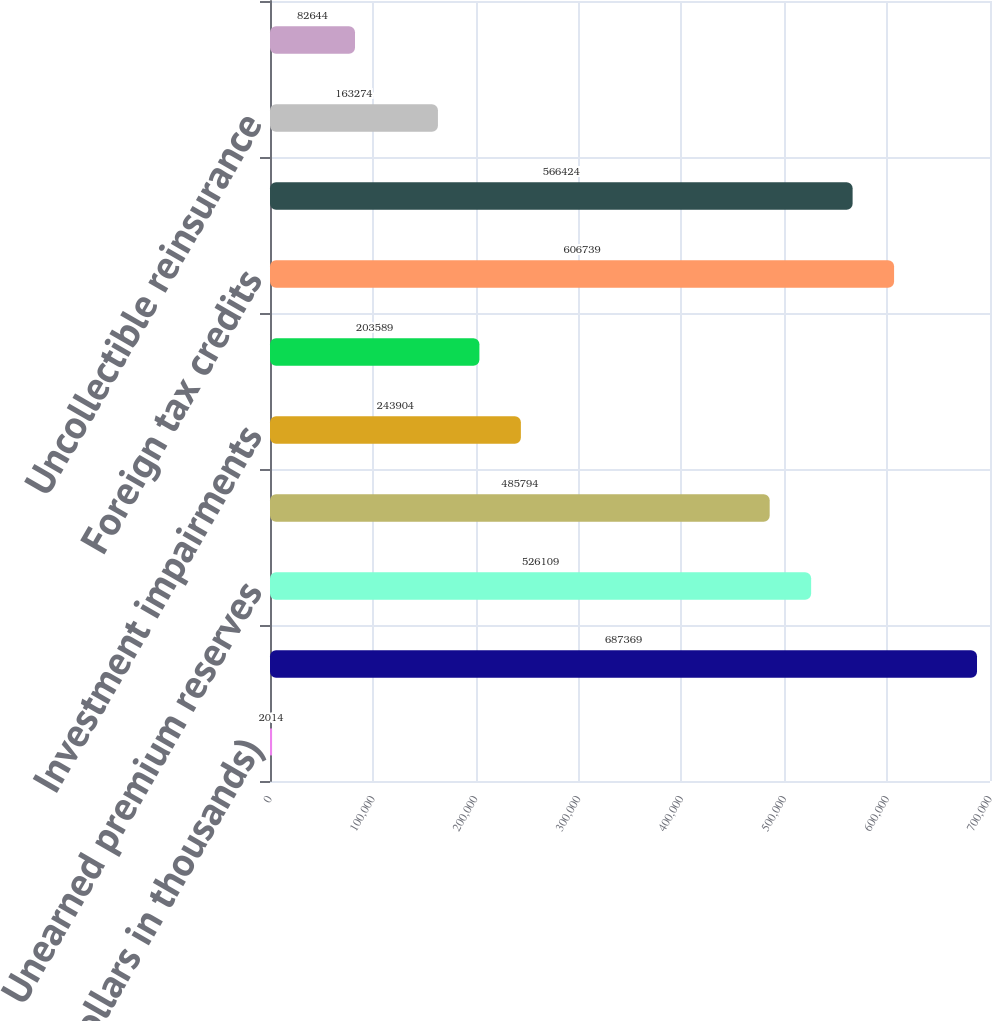Convert chart. <chart><loc_0><loc_0><loc_500><loc_500><bar_chart><fcel>(Dollars in thousands)<fcel>Loss reserves<fcel>Unearned premium reserves<fcel>Net unrecognized losses on<fcel>Investment impairments<fcel>Benefit plan liability<fcel>Foreign tax credits<fcel>Alternative minimum tax<fcel>Uncollectible reinsurance<fcel>Net operating loss<nl><fcel>2014<fcel>687369<fcel>526109<fcel>485794<fcel>243904<fcel>203589<fcel>606739<fcel>566424<fcel>163274<fcel>82644<nl></chart> 